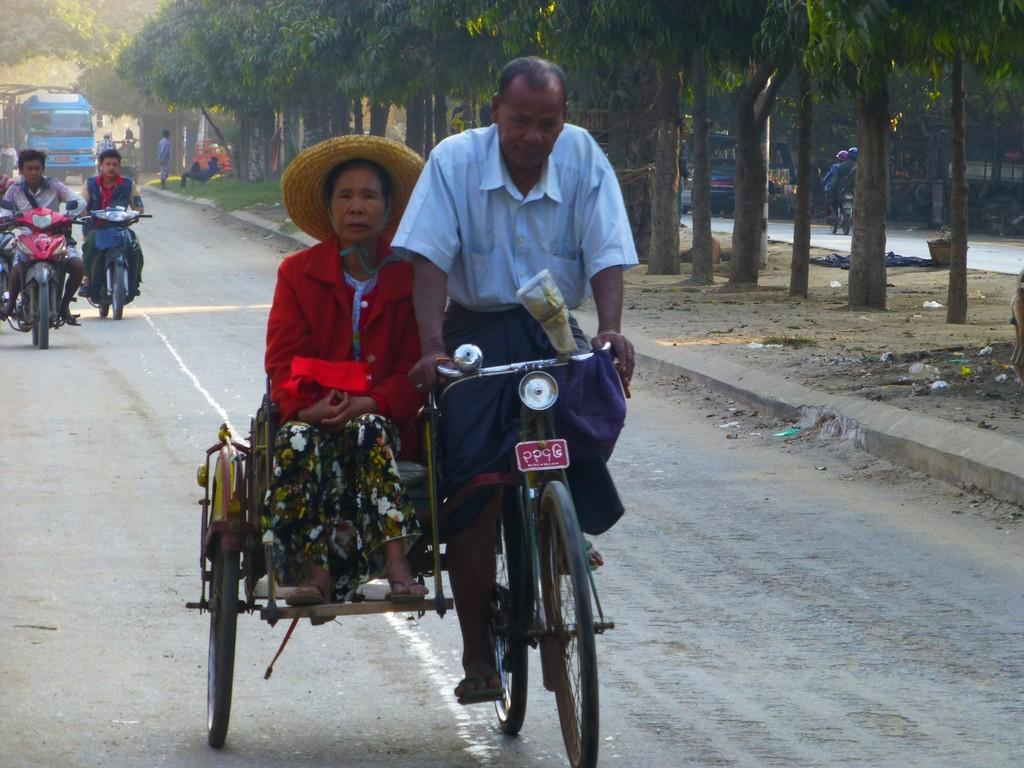What is the main subject of the image? There is a person riding a rickshaw in the image. Who is accompanying the person riding the rickshaw? A woman is sitting on the rickshaw. What can be seen in the background of the image? There are other vehicles on the road behind the rickshaw. What type of vegetation is visible in the image? There are many trees at the right side of the image. How many ladybugs can be seen on the rickshaw in the image? There are no ladybugs present on the rickshaw in the image. What type of town is depicted in the image? The image does not depict a town; it shows a person riding a rickshaw with a woman on it, surrounded by other vehicles and trees. 